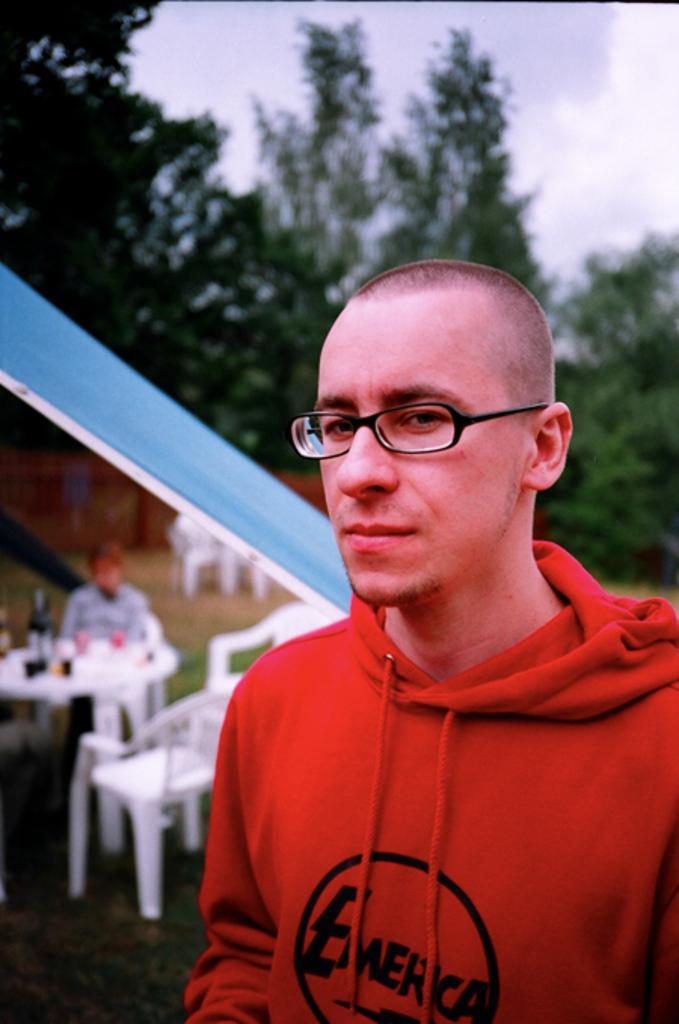Can you describe this image briefly? In this picture we can see a person wearing a spectacle. We can see chairs and some objects on the table. There is a person sitting on a chair. We can see some grass on the ground. There are other objects and the sky. 